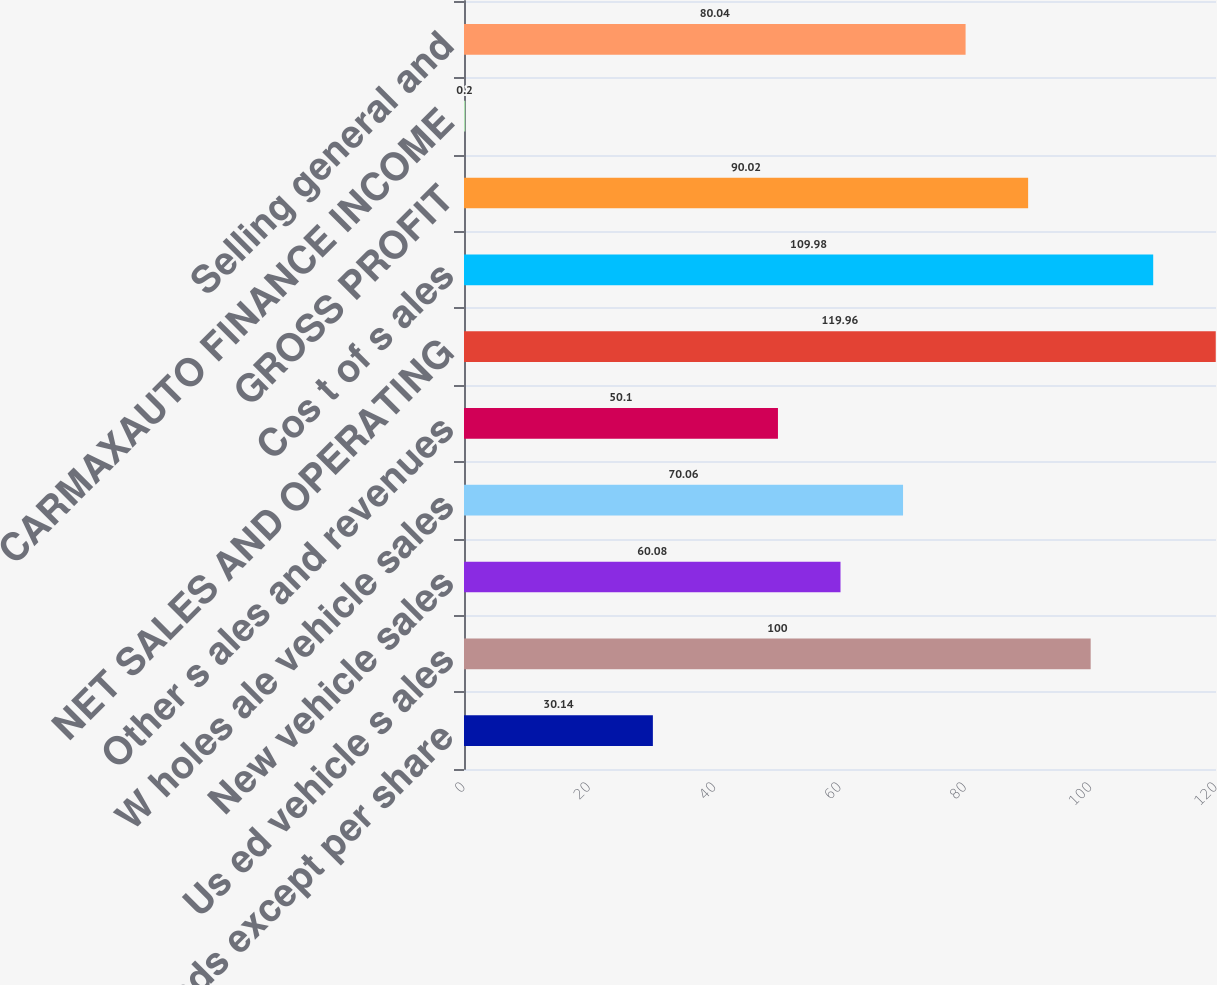Convert chart to OTSL. <chart><loc_0><loc_0><loc_500><loc_500><bar_chart><fcel>(In thousands except per share<fcel>Us ed vehicle s ales<fcel>New vehicle sales<fcel>W holes ale vehicle sales<fcel>Other s ales and revenues<fcel>NET SALES AND OPERATING<fcel>Cos t of s ales<fcel>GROSS PROFIT<fcel>CARMAXAUTO FINANCE INCOME<fcel>Selling general and<nl><fcel>30.14<fcel>100<fcel>60.08<fcel>70.06<fcel>50.1<fcel>119.96<fcel>109.98<fcel>90.02<fcel>0.2<fcel>80.04<nl></chart> 